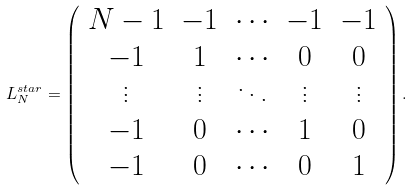Convert formula to latex. <formula><loc_0><loc_0><loc_500><loc_500>L ^ { s t a r } _ { N } = \left ( \begin{array} { c c c c c } { N - 1 } & - 1 & { \cdots } & - 1 & - 1 \\ - 1 & 1 & { \cdots } & 0 & 0 \\ { \vdots } & { \vdots } & { \ddots } & { \vdots } & { \vdots } \\ - 1 & 0 & { \cdots } & 1 & 0 \\ - 1 & 0 & { \cdots } & 0 & 1 \\ \end{array} \right ) .</formula> 